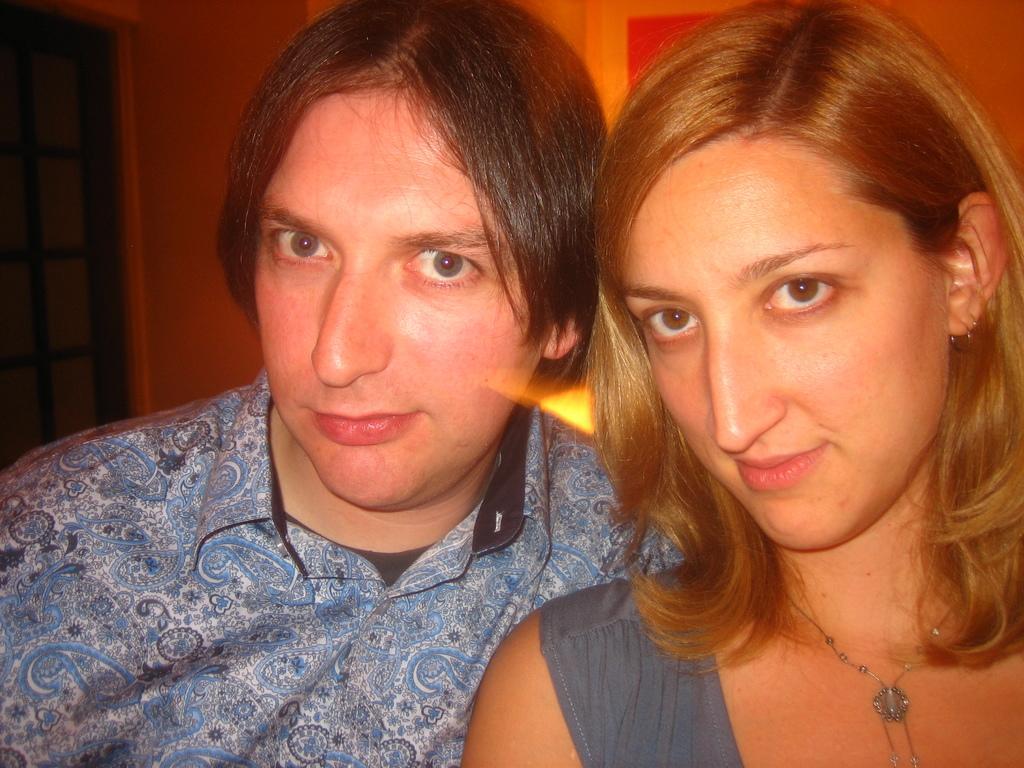Please provide a concise description of this image. In the image we can see a man and a woman smiling, they are wearing clothes and the woman is wearing neck chain and earring. This is a fence and a wall. 